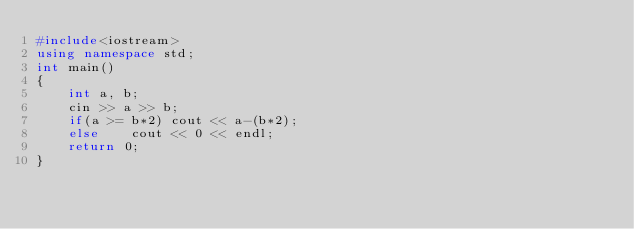<code> <loc_0><loc_0><loc_500><loc_500><_C++_>#include<iostream>
using namespace std;
int main()
{
    int a, b;
    cin >> a >> b;
    if(a >= b*2) cout << a-(b*2);
    else    cout << 0 << endl;
    return 0;
}</code> 